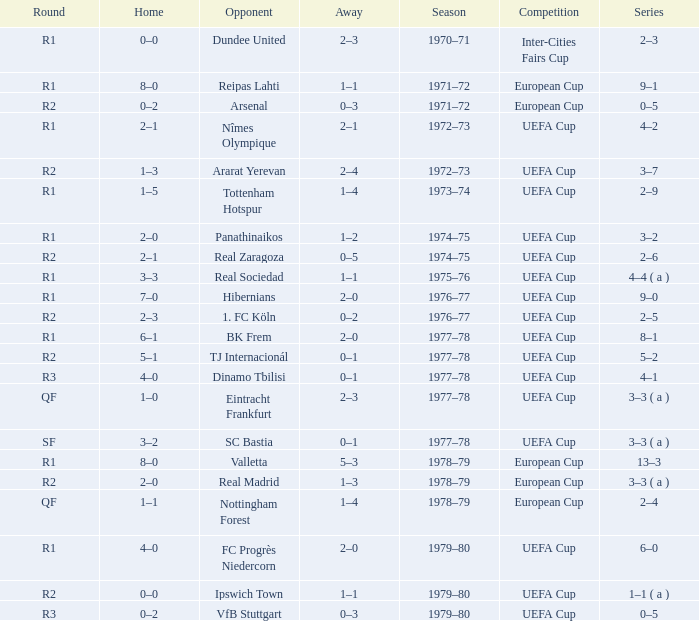Which Opponent has an Away of 1–1, and a Home of 3–3? Real Sociedad. 